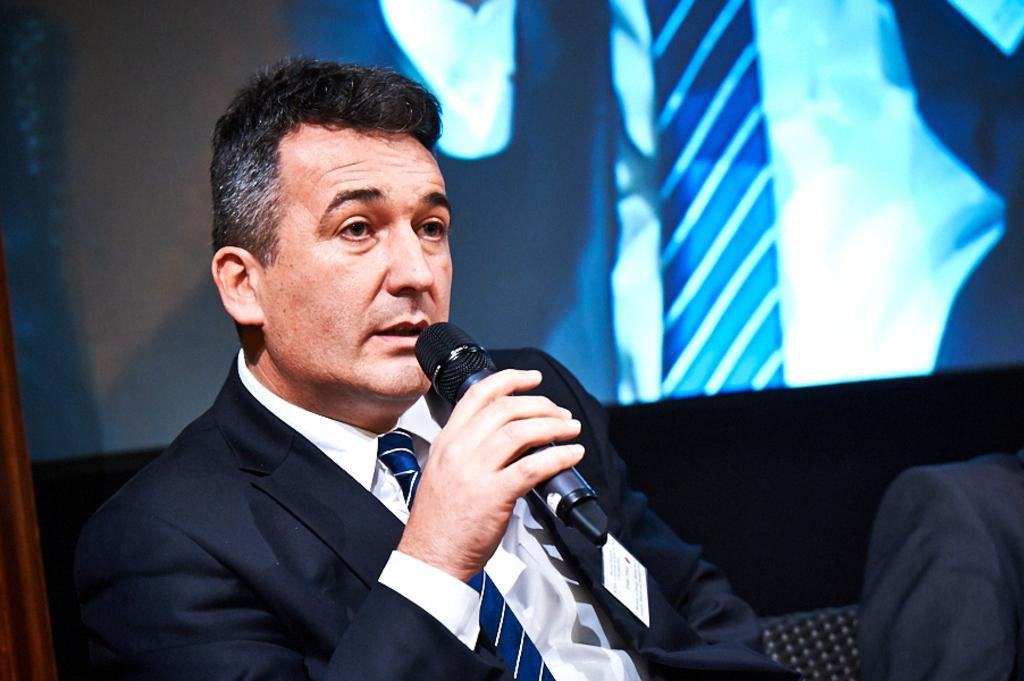What is the person in the image doing? The person is holding a microphone in their hand and their mouth is open. What object is the person holding? The person is holding a microphone in their hand. What can be seen on the screen in the image? The screen displays the time of the person. What might the person be doing based on the presence of the microphone and open mouth? The person might be speaking or singing into the microphone. What type of flower is on the calendar in the image? There is no flower or calendar present in the image. 